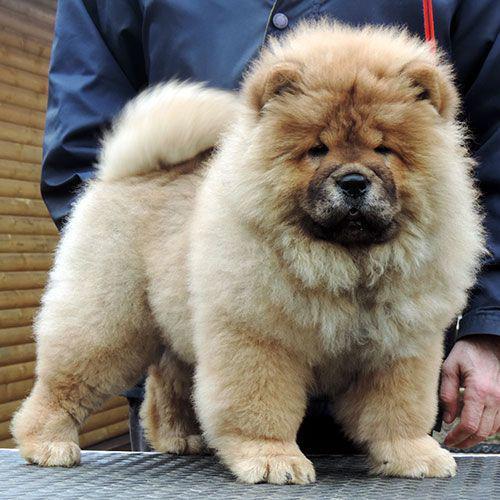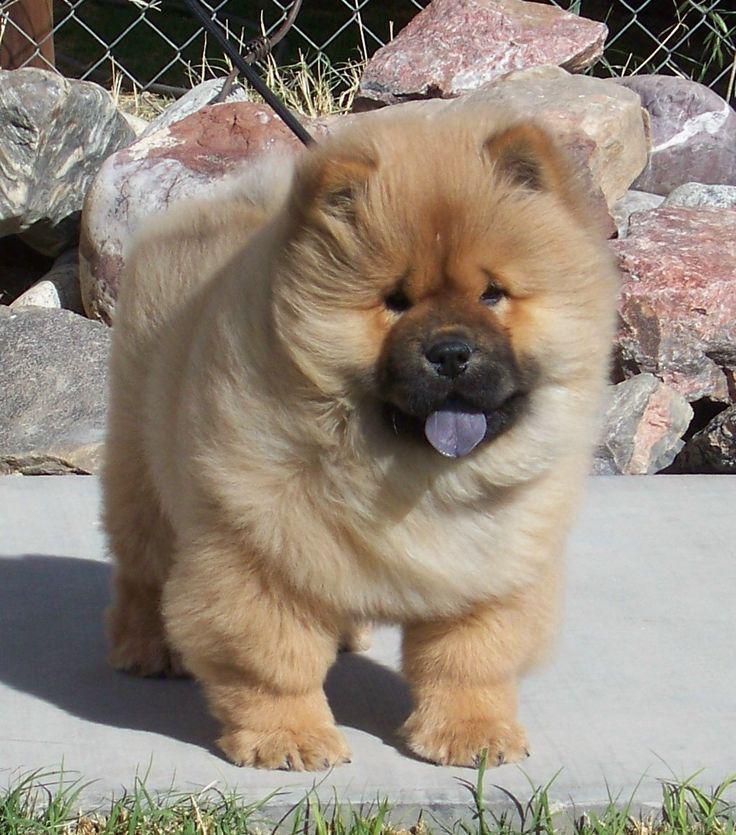The first image is the image on the left, the second image is the image on the right. Evaluate the accuracy of this statement regarding the images: "At least one dog is standing on hardwood floors.". Is it true? Answer yes or no. No. 